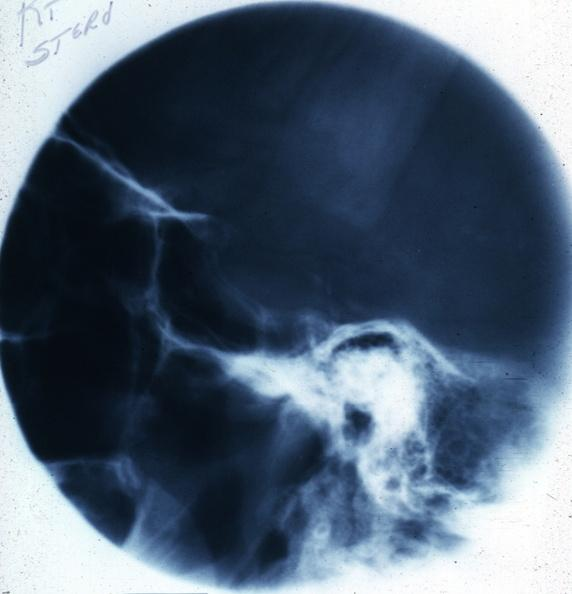what does this image show?
Answer the question using a single word or phrase. X-ray sella 